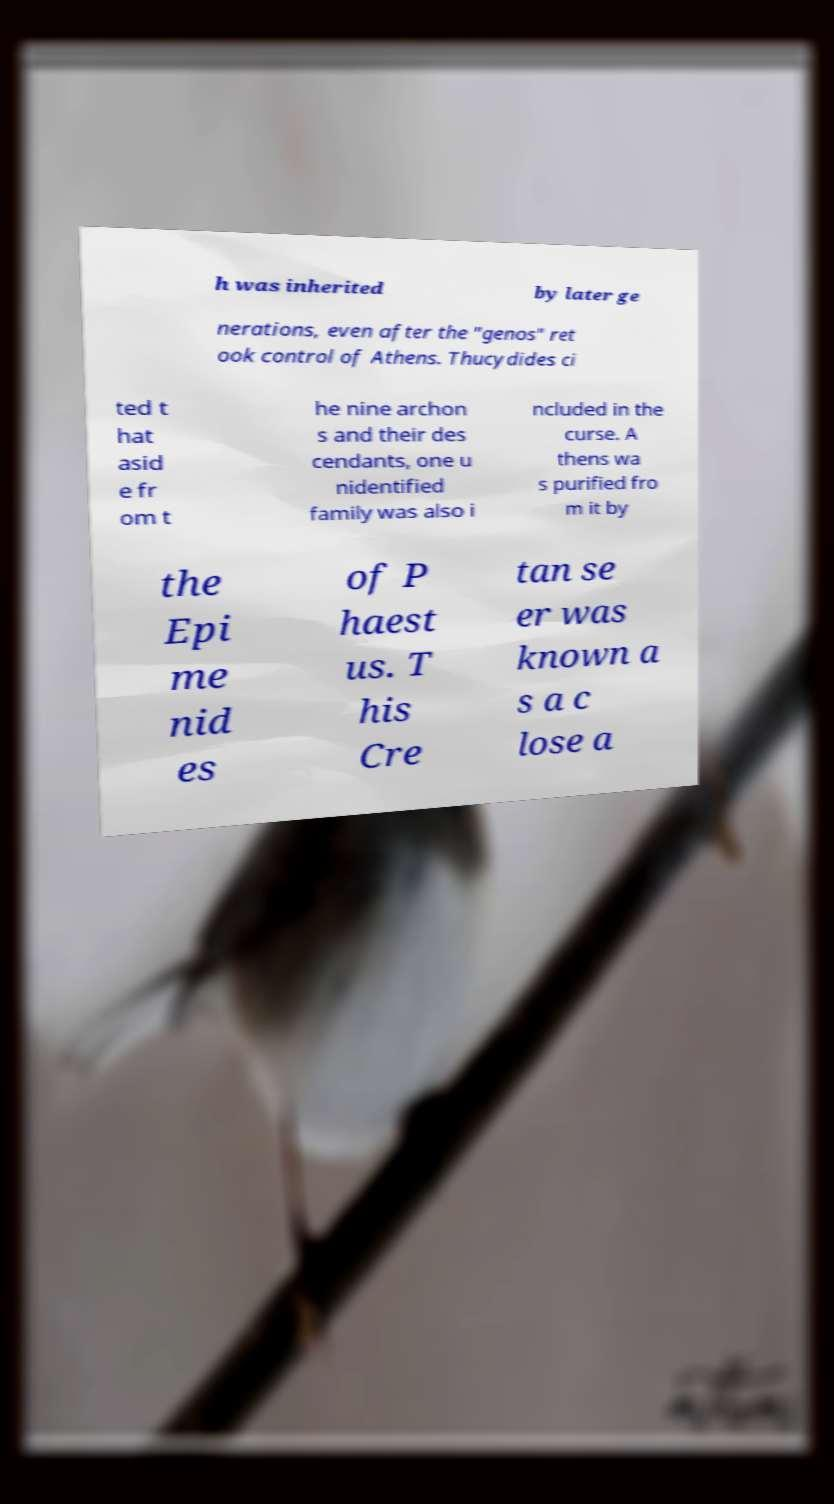Could you extract and type out the text from this image? h was inherited by later ge nerations, even after the "genos" ret ook control of Athens. Thucydides ci ted t hat asid e fr om t he nine archon s and their des cendants, one u nidentified family was also i ncluded in the curse. A thens wa s purified fro m it by the Epi me nid es of P haest us. T his Cre tan se er was known a s a c lose a 